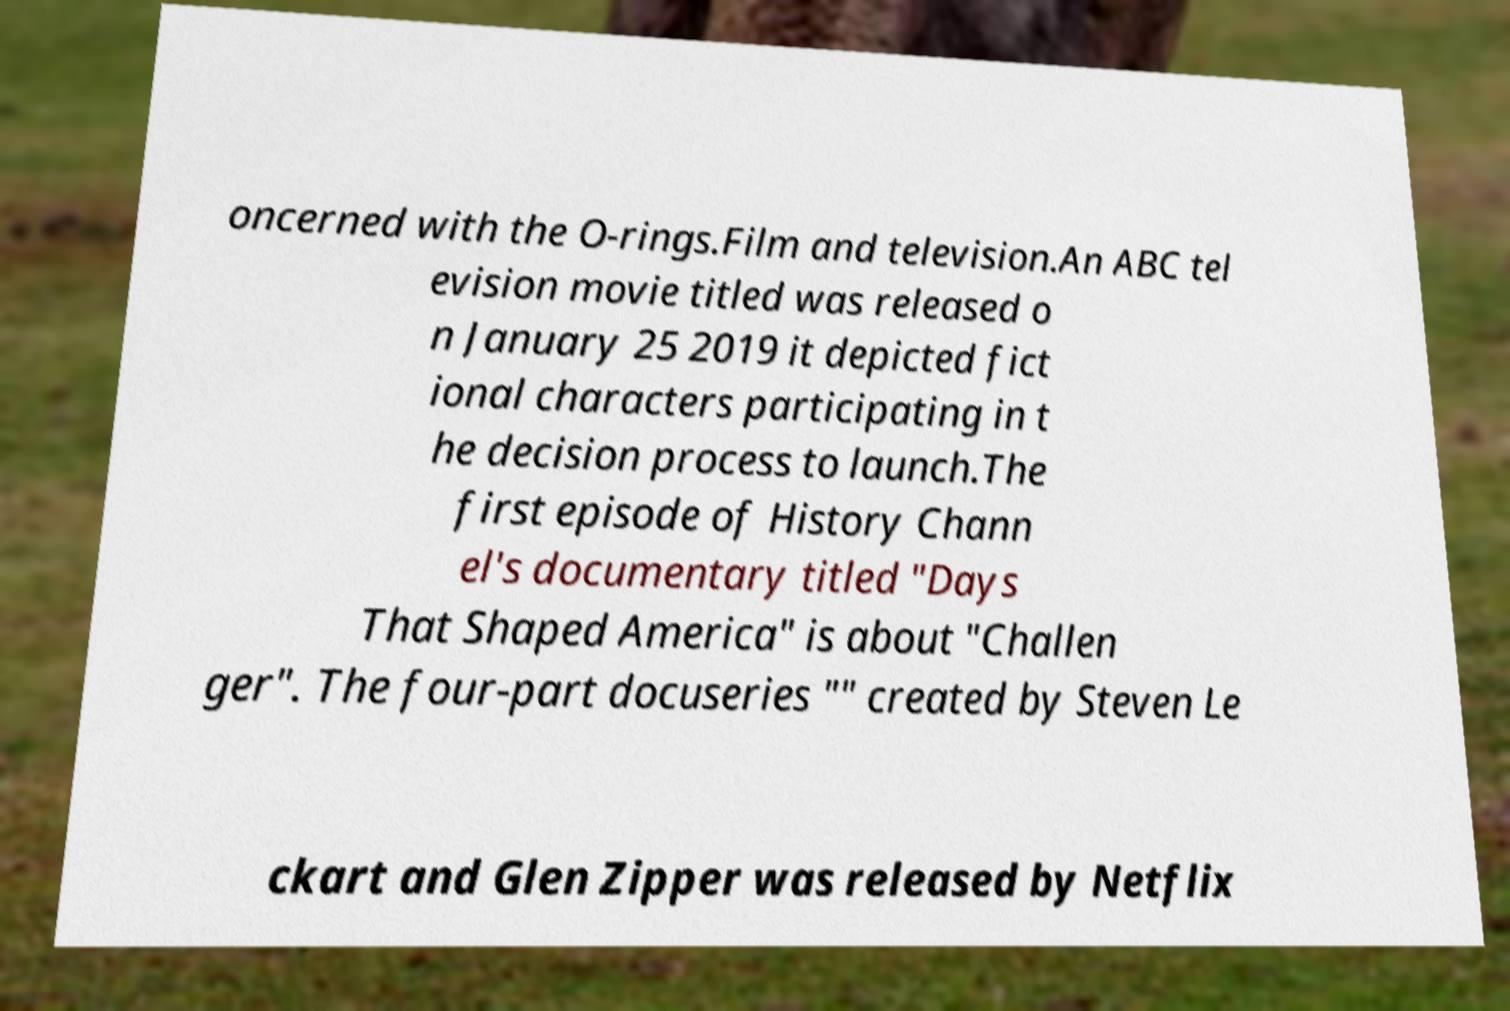What messages or text are displayed in this image? I need them in a readable, typed format. oncerned with the O-rings.Film and television.An ABC tel evision movie titled was released o n January 25 2019 it depicted fict ional characters participating in t he decision process to launch.The first episode of History Chann el's documentary titled "Days That Shaped America" is about "Challen ger". The four-part docuseries "" created by Steven Le ckart and Glen Zipper was released by Netflix 